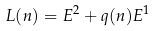Convert formula to latex. <formula><loc_0><loc_0><loc_500><loc_500>L ( n ) = E ^ { 2 } + q ( n ) E ^ { 1 }</formula> 